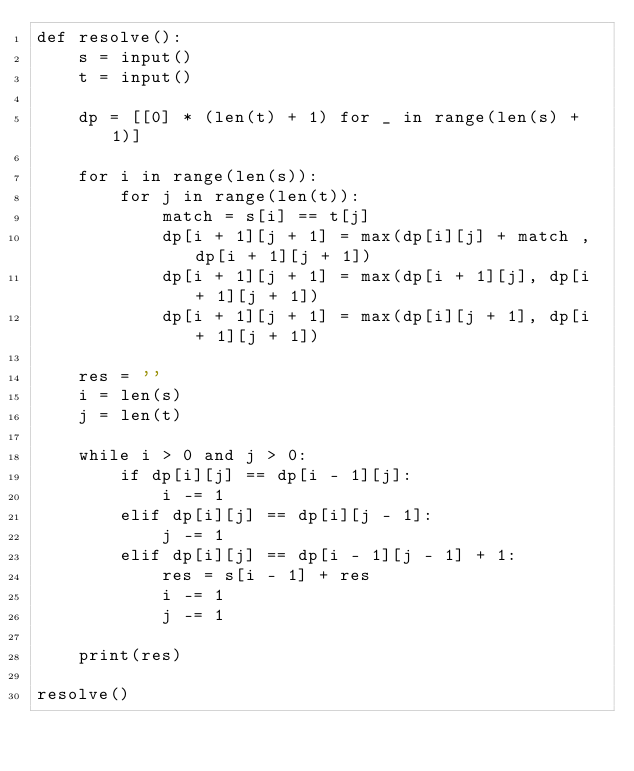Convert code to text. <code><loc_0><loc_0><loc_500><loc_500><_Python_>def resolve():
    s = input()
    t = input()

    dp = [[0] * (len(t) + 1) for _ in range(len(s) + 1)]

    for i in range(len(s)):
        for j in range(len(t)):
            match = s[i] == t[j]
            dp[i + 1][j + 1] = max(dp[i][j] + match , dp[i + 1][j + 1])
            dp[i + 1][j + 1] = max(dp[i + 1][j], dp[i + 1][j + 1])
            dp[i + 1][j + 1] = max(dp[i][j + 1], dp[i + 1][j + 1])

    res = ''
    i = len(s)
    j = len(t)

    while i > 0 and j > 0:
        if dp[i][j] == dp[i - 1][j]:
            i -= 1
        elif dp[i][j] == dp[i][j - 1]:
            j -= 1
        elif dp[i][j] == dp[i - 1][j - 1] + 1:
            res = s[i - 1] + res
            i -= 1
            j -= 1

    print(res)
    
resolve()</code> 